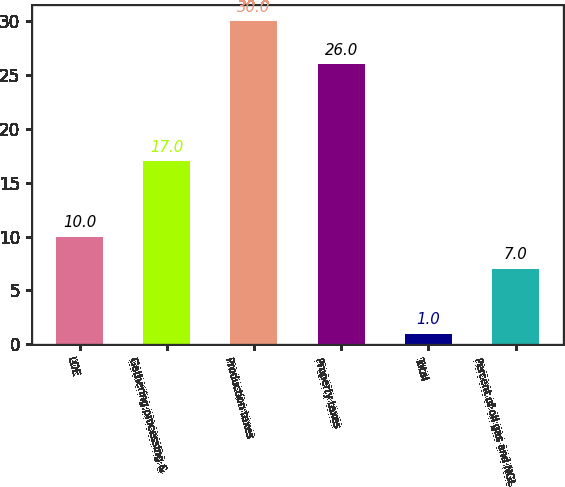Convert chart to OTSL. <chart><loc_0><loc_0><loc_500><loc_500><bar_chart><fcel>LOE<fcel>Gathering processing &<fcel>Production taxes<fcel>Property taxes<fcel>Total<fcel>Percent of oil gas and NGL<nl><fcel>10<fcel>17<fcel>30<fcel>26<fcel>1<fcel>7<nl></chart> 